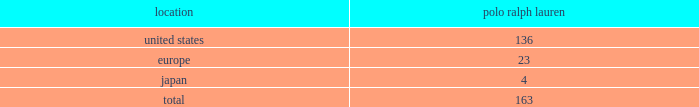In addition to generating sales of our products , our worldwide full-price stores set , reinforce and capitalize on the image of our brands .
Our stores range in size from approximately 800 to over 37500 square feet .
These full- price stores are situated in major upscale street locations and upscale regional malls , generally in large urban markets .
We generally lease our stores for initial periods ranging from 5 to 10 years with renewal options .
We extend our reach to additional consumer groups through our 163 polo ralph lauren factory stores worldwide .
During fiscal 2009 , we added 5 new polo ralph lauren factory stores , net .
Our factory stores are generally located in outlet malls .
We operated the following factory retail stores as of march 28 , 2009 : factory retail stores location ralph lauren .
2022 polo ralph lauren domestic factory stores offer selections of our menswear , womenswear , children 2019s apparel , accessories , home furnishings and fragrances .
Ranging in size from approximately 2700 to 20000 square feet , with an average of approximately 9200 square feet , these stores are principally located in major outlet centers in 36 states and puerto rico .
2022 european factory stores offer selections of our menswear , womenswear , children 2019s apparel , accessories , home furnishings and fragrances .
Ranging in size from approximately 2300 to 10500 square feet , with an average of approximately 6500 square feet , these stores are located in 9 countries , principally in major outlet centers .
2022 japanese factory stores offer selections of our menswear , womenswear , children 2019s apparel , accessories , home furnishings and fragrances .
Ranging in size from approximately 1500 to 12000 square feet , with an average of approximately 7400 square feet , these stores are located in 3 provinces , principally in major outlet centers .
Factory stores obtain products from our suppliers , our product licensing partners and our retail stores .
Ralphlauren.com and rugby.com in addition to our stores , our retail segment sells products online through our e-commerce websites , ralphlauren.com ( http://www.ralphlauren.com ) and rugby.com ( http://www.rugby.com ) .
Ralphlauren.com offers our customers access to the full breadth of ralph lauren apparel , accessories and home products , allows us to reach retail customers on a multi-channel basis and reinforces the luxury image of our brands .
Ralphlauren.com averaged 2.9 million unique visitors a month and acquired approximately 350000 new customers , resulting in 1.7 million total customers in fiscal 2009 .
In august 2008 , the company launched rugby.com , its second e-commerce website .
Rugby.com offers clothing and accessories for purchase 2014 previously only available at rugby stores 2014 along with style tips , unique videos and blog-based content .
Rugby.com offers an extensive array of rugby products for young men and women within a full lifestyle destination .
Our licensing segment through licensing alliances , we combine our consumer insight , design , and marketing skills with the specific product or geographic competencies of our licensing partners to create and build new businesses .
We generally seek out licensing partners who : 2022 are leaders in their respective markets ; 2022 contribute the majority of the product development costs; .
What percentage of factory retail stores as of march 28 , 2009 were located in the europe? 
Computations: (23 / 163)
Answer: 0.1411. 